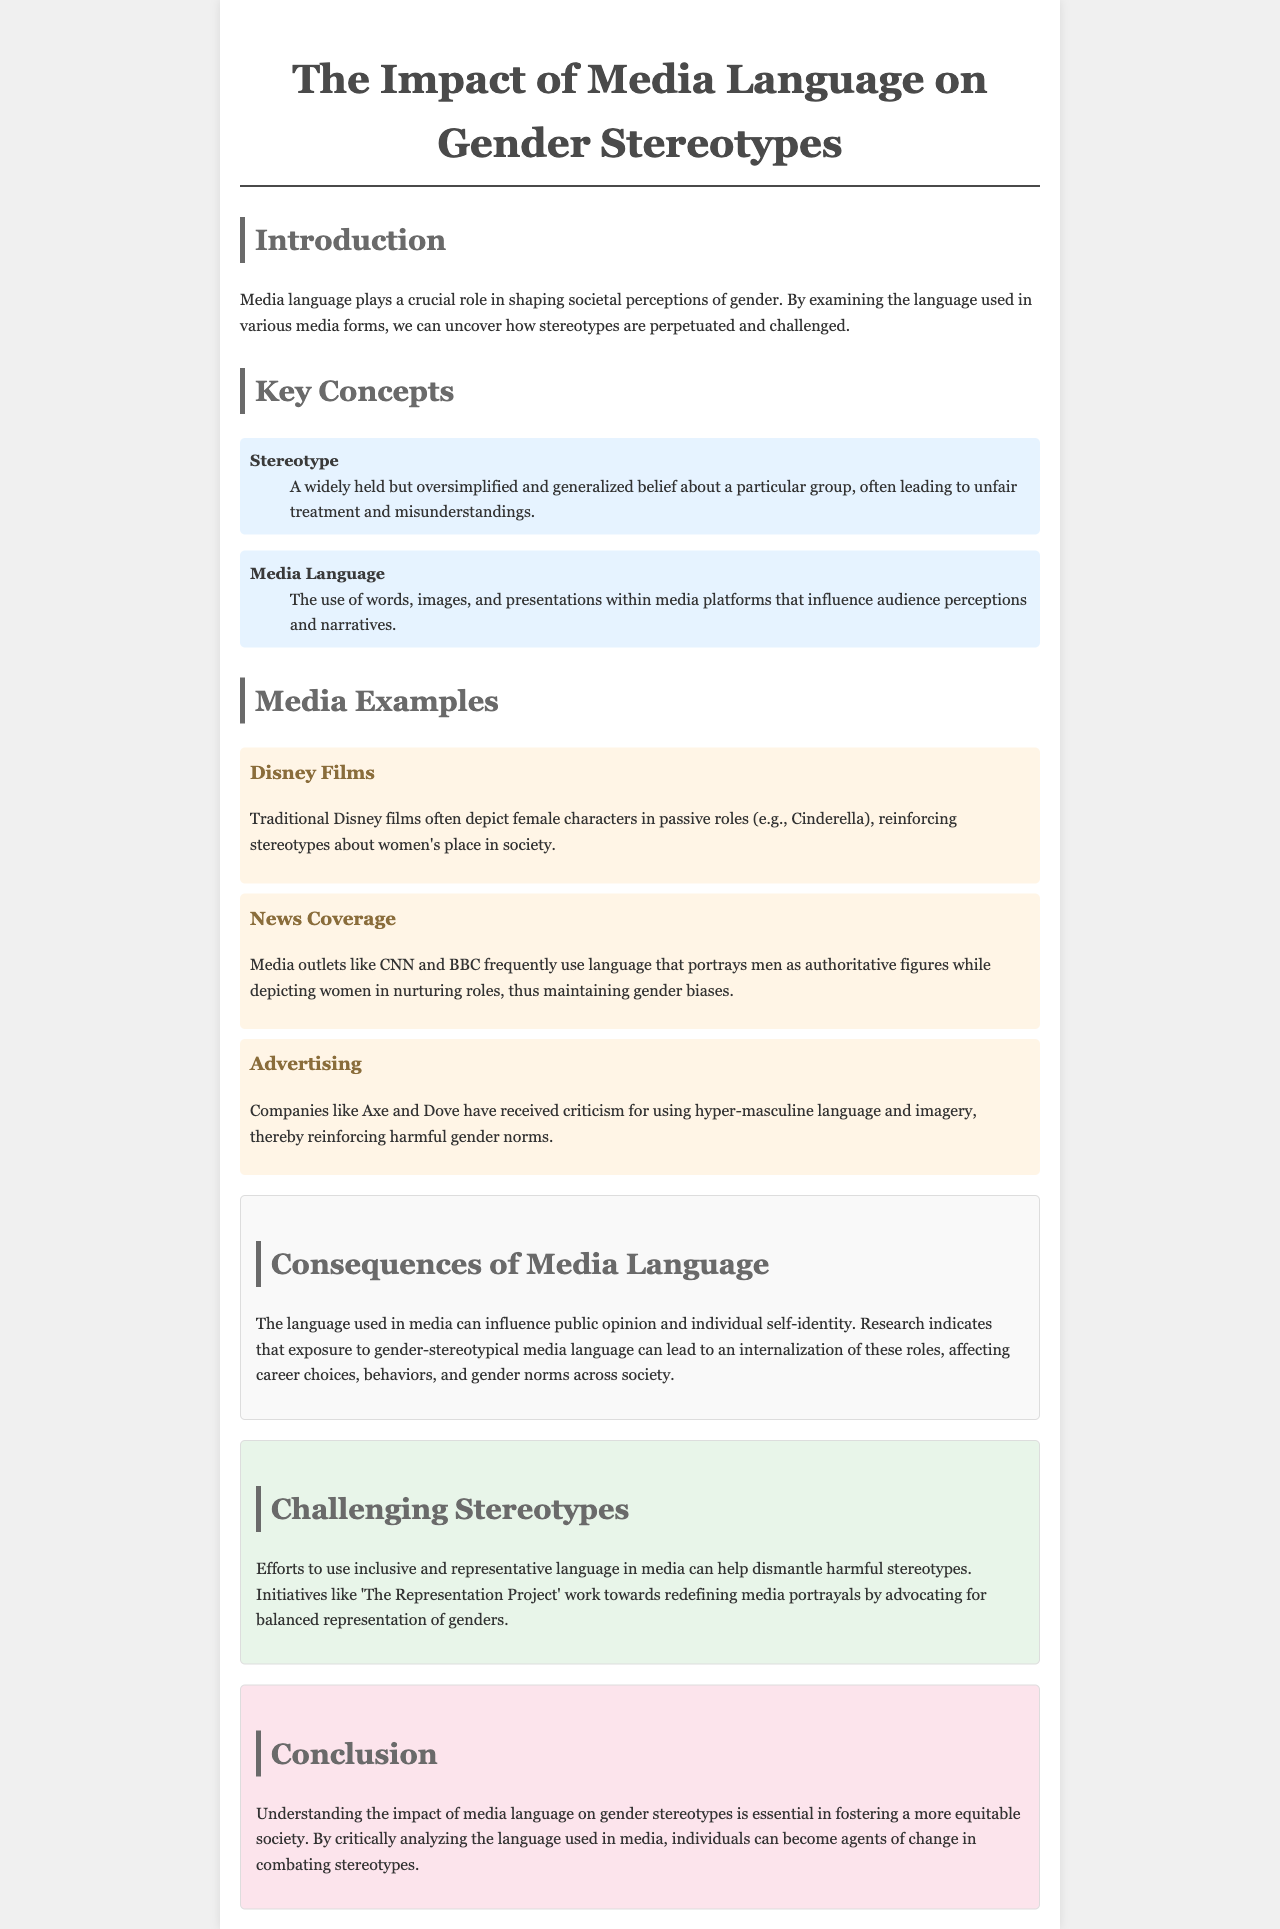What is the title of the document? The title of the document is prominently displayed at the top.
Answer: The Impact of Media Language on Gender Stereotypes What is a stereotype? A definition of a stereotype is provided in the key concepts section.
Answer: A widely held but oversimplified and generalized belief about a particular group, often leading to unfair treatment and misunderstandings Which media example depicts female characters in passive roles? The brochure lists Disney films as an example where female characters are often shown in passive roles.
Answer: Disney Films What type of company has received criticism for using hyper-masculine language? The document mentions specific companies associated with this criticism.
Answer: Companies like Axe and Dove What does the section on consequences discuss? This section outlines the effects of media language on public opinion and individual self-identity.
Answer: Influence on public opinion and individual self-identity What initiative works towards redefining media portrayals? The brochure highlights a specific initiative aimed at challenging stereotypes.
Answer: The Representation Project What color is used for the consequences section? The document specifies the background color used in this section.
Answer: Light gray How does the document suggest individuals can combat stereotypes? The conclusion section discusses the role of individuals in challenging stereotypes.
Answer: By critically analyzing the language used in media 